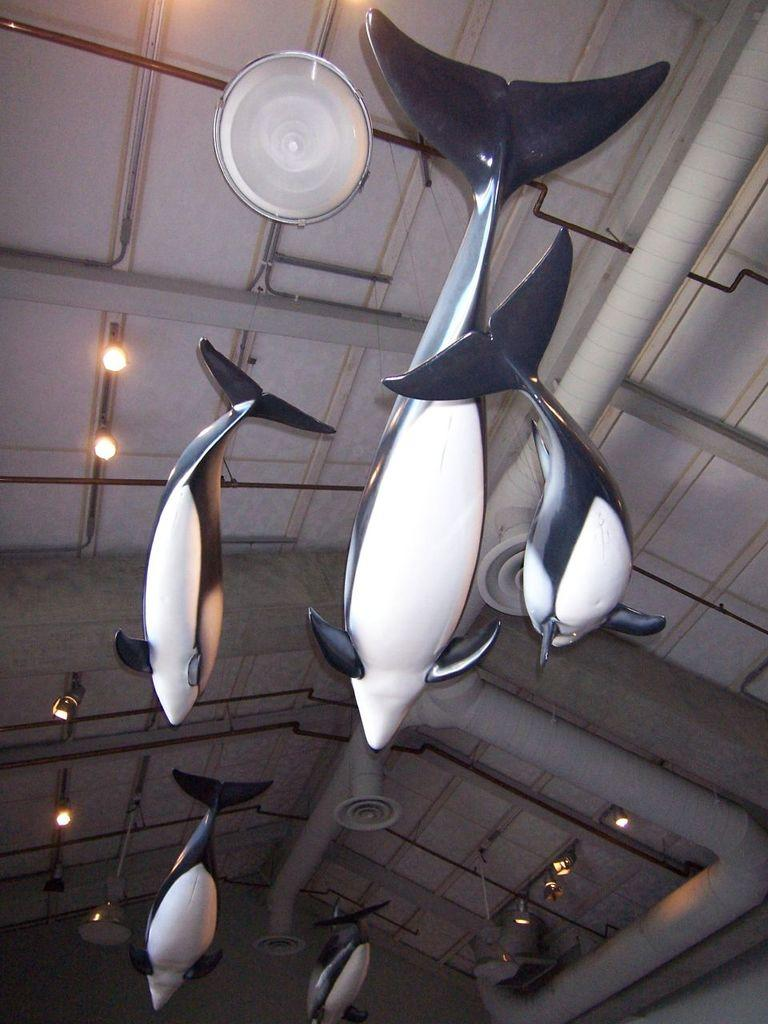What type of toys are visible in the image? There are fish toys in the image. How are the fish toys positioned in the image? The fish toys are hanging from the roof. Are there any additional features attached to the fish toys? Yes, there are lights attached to the fish toys. What type of lunch can be seen in the image? There is no lunch present in the image; it features fish toys hanging from the roof with lights attached. 